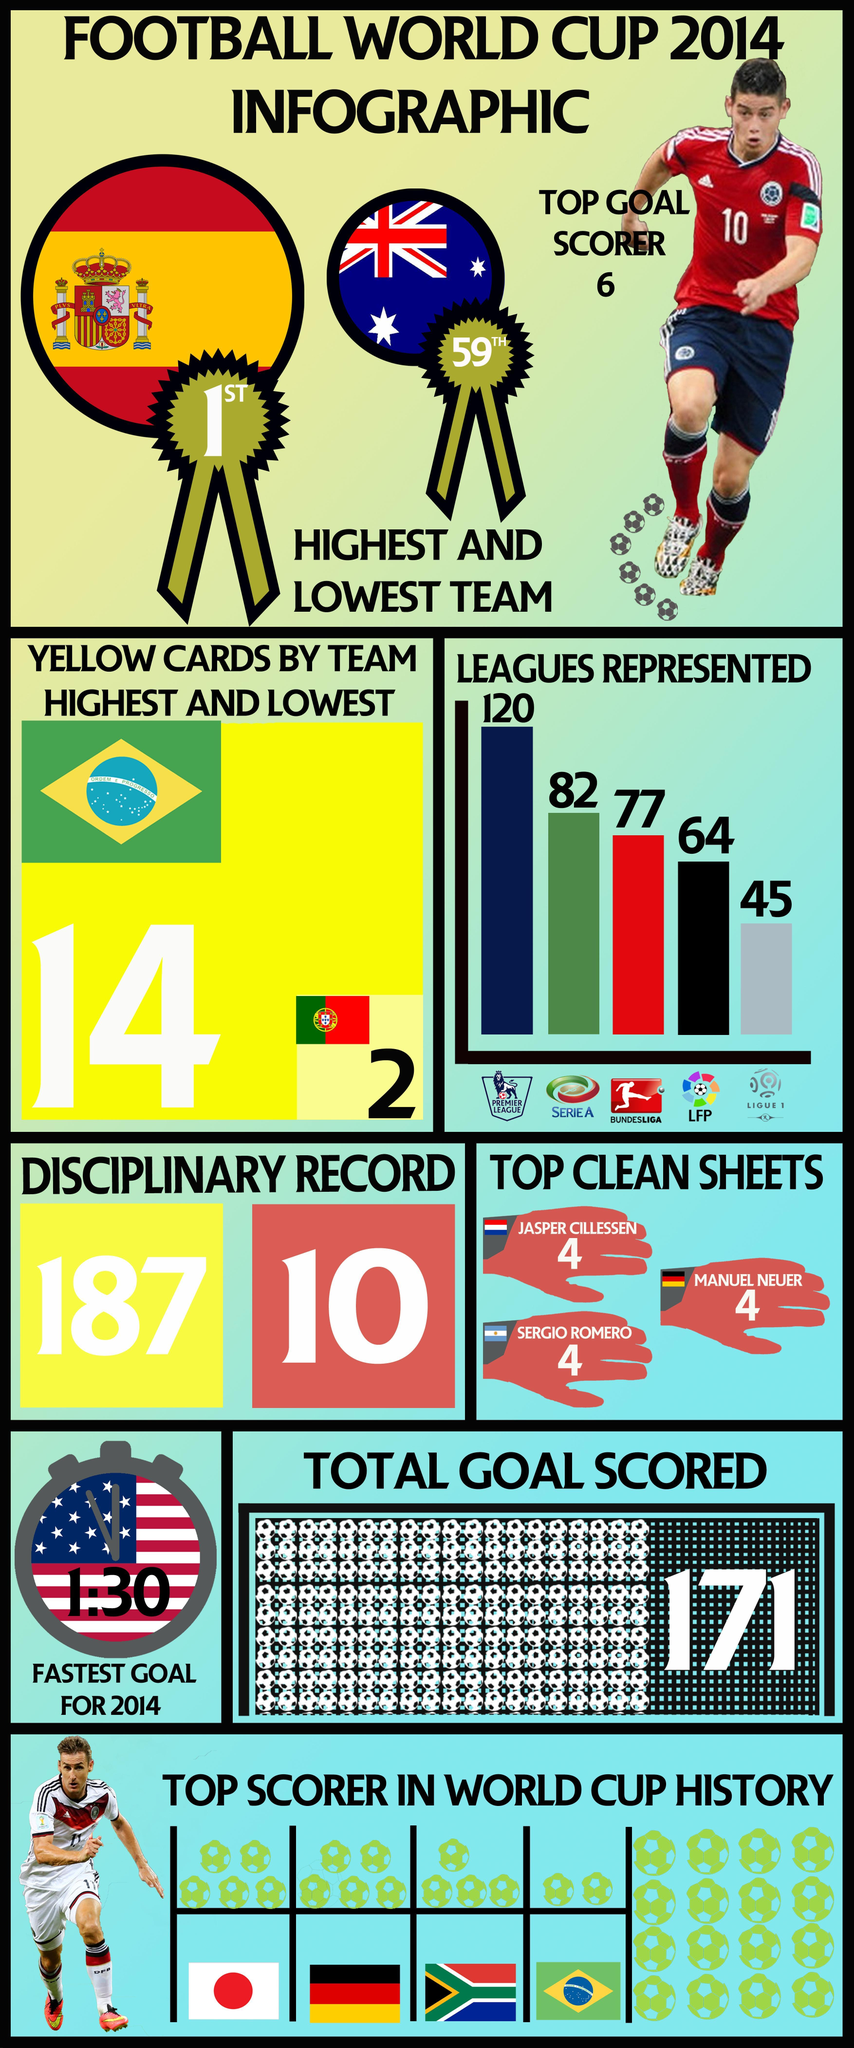Which league is represented by red colour on the bar chart?
Answer the question with a short phrase. BUNDESLIGA 